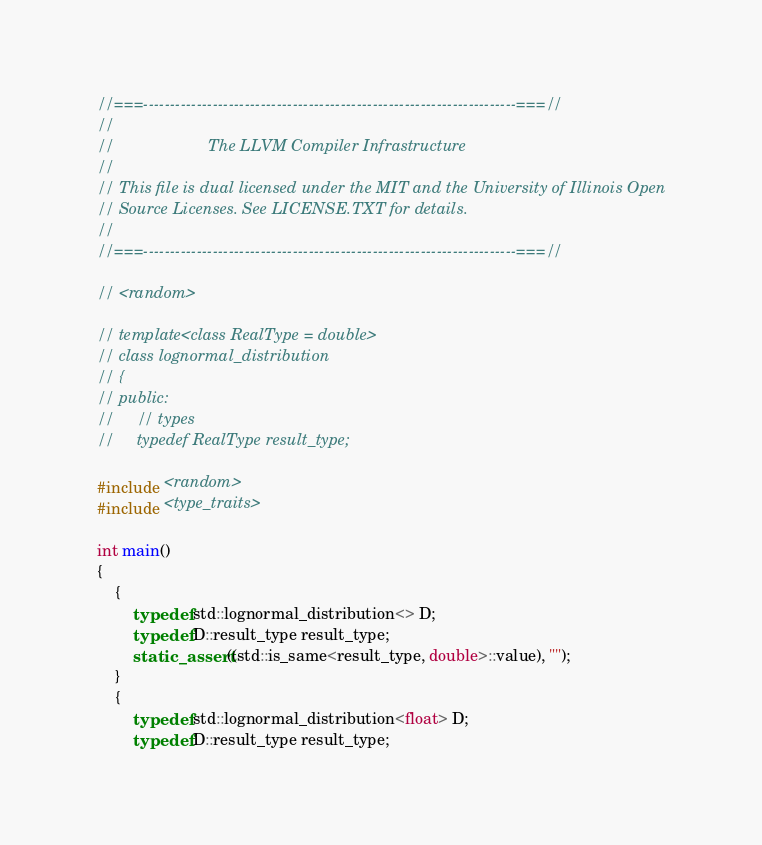<code> <loc_0><loc_0><loc_500><loc_500><_C++_>//===----------------------------------------------------------------------===//
//
//                     The LLVM Compiler Infrastructure
//
// This file is dual licensed under the MIT and the University of Illinois Open
// Source Licenses. See LICENSE.TXT for details.
//
//===----------------------------------------------------------------------===//

// <random>

// template<class RealType = double>
// class lognormal_distribution
// {
// public:
//     // types
//     typedef RealType result_type;

#include <random>
#include <type_traits>

int main()
{
    {
        typedef std::lognormal_distribution<> D;
        typedef D::result_type result_type;
        static_assert((std::is_same<result_type, double>::value), "");
    }
    {
        typedef std::lognormal_distribution<float> D;
        typedef D::result_type result_type;</code> 